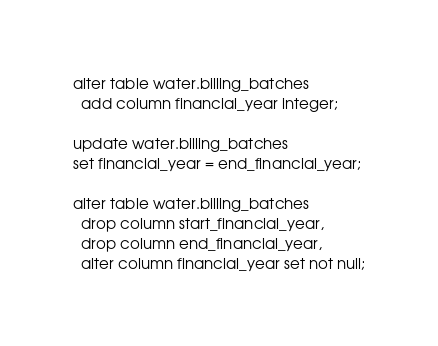Convert code to text. <code><loc_0><loc_0><loc_500><loc_500><_SQL_>alter table water.billing_batches
  add column financial_year integer;

update water.billing_batches
set financial_year = end_financial_year;

alter table water.billing_batches
  drop column start_financial_year,
  drop column end_financial_year,
  alter column financial_year set not null;
</code> 